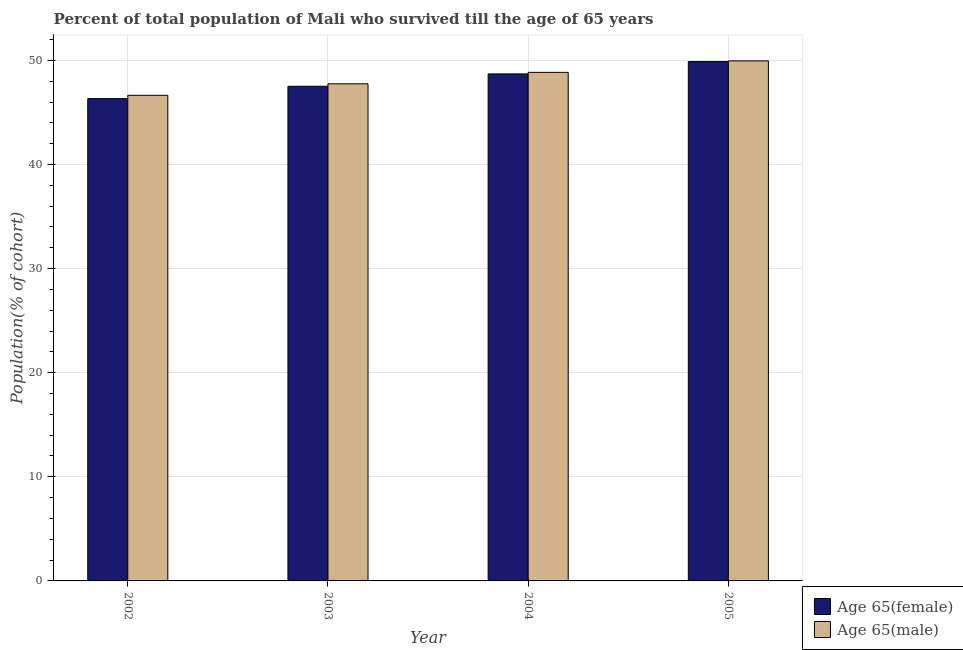How many different coloured bars are there?
Your answer should be compact. 2. Are the number of bars per tick equal to the number of legend labels?
Keep it short and to the point. Yes. How many bars are there on the 4th tick from the left?
Your answer should be compact. 2. How many bars are there on the 1st tick from the right?
Offer a terse response. 2. What is the label of the 2nd group of bars from the left?
Your answer should be compact. 2003. In how many cases, is the number of bars for a given year not equal to the number of legend labels?
Your response must be concise. 0. What is the percentage of male population who survived till age of 65 in 2004?
Provide a succinct answer. 48.85. Across all years, what is the maximum percentage of female population who survived till age of 65?
Keep it short and to the point. 49.88. Across all years, what is the minimum percentage of male population who survived till age of 65?
Offer a very short reply. 46.64. In which year was the percentage of male population who survived till age of 65 minimum?
Provide a short and direct response. 2002. What is the total percentage of female population who survived till age of 65 in the graph?
Give a very brief answer. 192.42. What is the difference between the percentage of male population who survived till age of 65 in 2003 and that in 2004?
Provide a short and direct response. -1.1. What is the difference between the percentage of male population who survived till age of 65 in 2005 and the percentage of female population who survived till age of 65 in 2002?
Your answer should be very brief. 3.31. What is the average percentage of female population who survived till age of 65 per year?
Your answer should be compact. 48.11. In the year 2003, what is the difference between the percentage of male population who survived till age of 65 and percentage of female population who survived till age of 65?
Provide a succinct answer. 0. In how many years, is the percentage of male population who survived till age of 65 greater than 32 %?
Provide a short and direct response. 4. What is the ratio of the percentage of female population who survived till age of 65 in 2004 to that in 2005?
Offer a terse response. 0.98. Is the percentage of female population who survived till age of 65 in 2003 less than that in 2005?
Provide a short and direct response. Yes. Is the difference between the percentage of female population who survived till age of 65 in 2002 and 2005 greater than the difference between the percentage of male population who survived till age of 65 in 2002 and 2005?
Provide a succinct answer. No. What is the difference between the highest and the second highest percentage of male population who survived till age of 65?
Your response must be concise. 1.1. What is the difference between the highest and the lowest percentage of male population who survived till age of 65?
Offer a terse response. 3.31. In how many years, is the percentage of female population who survived till age of 65 greater than the average percentage of female population who survived till age of 65 taken over all years?
Your answer should be compact. 2. Is the sum of the percentage of female population who survived till age of 65 in 2004 and 2005 greater than the maximum percentage of male population who survived till age of 65 across all years?
Give a very brief answer. Yes. What does the 1st bar from the left in 2003 represents?
Provide a short and direct response. Age 65(female). What does the 1st bar from the right in 2002 represents?
Give a very brief answer. Age 65(male). How many bars are there?
Your answer should be very brief. 8. What is the difference between two consecutive major ticks on the Y-axis?
Ensure brevity in your answer.  10. Are the values on the major ticks of Y-axis written in scientific E-notation?
Provide a succinct answer. No. Does the graph contain grids?
Provide a succinct answer. Yes. Where does the legend appear in the graph?
Give a very brief answer. Bottom right. How many legend labels are there?
Offer a terse response. 2. What is the title of the graph?
Your response must be concise. Percent of total population of Mali who survived till the age of 65 years. Does "Quality of trade" appear as one of the legend labels in the graph?
Your response must be concise. No. What is the label or title of the X-axis?
Your response must be concise. Year. What is the label or title of the Y-axis?
Keep it short and to the point. Population(% of cohort). What is the Population(% of cohort) in Age 65(female) in 2002?
Your answer should be very brief. 46.33. What is the Population(% of cohort) of Age 65(male) in 2002?
Provide a succinct answer. 46.64. What is the Population(% of cohort) of Age 65(female) in 2003?
Keep it short and to the point. 47.51. What is the Population(% of cohort) of Age 65(male) in 2003?
Your answer should be compact. 47.75. What is the Population(% of cohort) of Age 65(female) in 2004?
Keep it short and to the point. 48.7. What is the Population(% of cohort) of Age 65(male) in 2004?
Keep it short and to the point. 48.85. What is the Population(% of cohort) of Age 65(female) in 2005?
Offer a terse response. 49.88. What is the Population(% of cohort) in Age 65(male) in 2005?
Offer a terse response. 49.95. Across all years, what is the maximum Population(% of cohort) in Age 65(female)?
Offer a very short reply. 49.88. Across all years, what is the maximum Population(% of cohort) of Age 65(male)?
Provide a short and direct response. 49.95. Across all years, what is the minimum Population(% of cohort) in Age 65(female)?
Offer a very short reply. 46.33. Across all years, what is the minimum Population(% of cohort) of Age 65(male)?
Your response must be concise. 46.64. What is the total Population(% of cohort) of Age 65(female) in the graph?
Provide a succinct answer. 192.42. What is the total Population(% of cohort) of Age 65(male) in the graph?
Give a very brief answer. 193.19. What is the difference between the Population(% of cohort) in Age 65(female) in 2002 and that in 2003?
Offer a very short reply. -1.19. What is the difference between the Population(% of cohort) in Age 65(male) in 2002 and that in 2003?
Offer a terse response. -1.1. What is the difference between the Population(% of cohort) of Age 65(female) in 2002 and that in 2004?
Provide a short and direct response. -2.37. What is the difference between the Population(% of cohort) in Age 65(male) in 2002 and that in 2004?
Your answer should be very brief. -2.2. What is the difference between the Population(% of cohort) of Age 65(female) in 2002 and that in 2005?
Offer a terse response. -3.56. What is the difference between the Population(% of cohort) in Age 65(male) in 2002 and that in 2005?
Keep it short and to the point. -3.31. What is the difference between the Population(% of cohort) of Age 65(female) in 2003 and that in 2004?
Your answer should be very brief. -1.19. What is the difference between the Population(% of cohort) of Age 65(male) in 2003 and that in 2004?
Offer a terse response. -1.1. What is the difference between the Population(% of cohort) in Age 65(female) in 2003 and that in 2005?
Offer a terse response. -2.37. What is the difference between the Population(% of cohort) in Age 65(male) in 2003 and that in 2005?
Offer a terse response. -2.2. What is the difference between the Population(% of cohort) of Age 65(female) in 2004 and that in 2005?
Ensure brevity in your answer.  -1.19. What is the difference between the Population(% of cohort) in Age 65(male) in 2004 and that in 2005?
Provide a succinct answer. -1.1. What is the difference between the Population(% of cohort) of Age 65(female) in 2002 and the Population(% of cohort) of Age 65(male) in 2003?
Offer a terse response. -1.42. What is the difference between the Population(% of cohort) of Age 65(female) in 2002 and the Population(% of cohort) of Age 65(male) in 2004?
Your response must be concise. -2.52. What is the difference between the Population(% of cohort) of Age 65(female) in 2002 and the Population(% of cohort) of Age 65(male) in 2005?
Ensure brevity in your answer.  -3.63. What is the difference between the Population(% of cohort) in Age 65(female) in 2003 and the Population(% of cohort) in Age 65(male) in 2004?
Your answer should be compact. -1.34. What is the difference between the Population(% of cohort) of Age 65(female) in 2003 and the Population(% of cohort) of Age 65(male) in 2005?
Make the answer very short. -2.44. What is the difference between the Population(% of cohort) of Age 65(female) in 2004 and the Population(% of cohort) of Age 65(male) in 2005?
Offer a very short reply. -1.25. What is the average Population(% of cohort) of Age 65(female) per year?
Offer a terse response. 48.1. What is the average Population(% of cohort) in Age 65(male) per year?
Your answer should be very brief. 48.3. In the year 2002, what is the difference between the Population(% of cohort) of Age 65(female) and Population(% of cohort) of Age 65(male)?
Provide a short and direct response. -0.32. In the year 2003, what is the difference between the Population(% of cohort) in Age 65(female) and Population(% of cohort) in Age 65(male)?
Your answer should be compact. -0.24. In the year 2004, what is the difference between the Population(% of cohort) of Age 65(female) and Population(% of cohort) of Age 65(male)?
Your answer should be compact. -0.15. In the year 2005, what is the difference between the Population(% of cohort) of Age 65(female) and Population(% of cohort) of Age 65(male)?
Your answer should be very brief. -0.07. What is the ratio of the Population(% of cohort) in Age 65(male) in 2002 to that in 2003?
Keep it short and to the point. 0.98. What is the ratio of the Population(% of cohort) of Age 65(female) in 2002 to that in 2004?
Your response must be concise. 0.95. What is the ratio of the Population(% of cohort) of Age 65(male) in 2002 to that in 2004?
Your answer should be compact. 0.95. What is the ratio of the Population(% of cohort) of Age 65(female) in 2002 to that in 2005?
Give a very brief answer. 0.93. What is the ratio of the Population(% of cohort) of Age 65(male) in 2002 to that in 2005?
Your answer should be very brief. 0.93. What is the ratio of the Population(% of cohort) in Age 65(female) in 2003 to that in 2004?
Offer a very short reply. 0.98. What is the ratio of the Population(% of cohort) of Age 65(male) in 2003 to that in 2004?
Offer a very short reply. 0.98. What is the ratio of the Population(% of cohort) in Age 65(male) in 2003 to that in 2005?
Your response must be concise. 0.96. What is the ratio of the Population(% of cohort) in Age 65(female) in 2004 to that in 2005?
Keep it short and to the point. 0.98. What is the ratio of the Population(% of cohort) in Age 65(male) in 2004 to that in 2005?
Provide a short and direct response. 0.98. What is the difference between the highest and the second highest Population(% of cohort) of Age 65(female)?
Give a very brief answer. 1.19. What is the difference between the highest and the second highest Population(% of cohort) of Age 65(male)?
Provide a short and direct response. 1.1. What is the difference between the highest and the lowest Population(% of cohort) in Age 65(female)?
Provide a short and direct response. 3.56. What is the difference between the highest and the lowest Population(% of cohort) in Age 65(male)?
Offer a terse response. 3.31. 